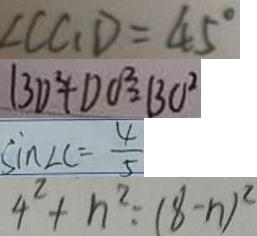Convert formula to latex. <formula><loc_0><loc_0><loc_500><loc_500>\angle C C _ { 1 } D = 4 5 ^ { \circ } 
 B D ^ { 2 } + D O ^ { 2 } = B O ^ { 2 } 
 \sin \angle C = \frac { 4 } { 5 } 
 4 ^ { 2 } + n ^ { 2 } : ( 8 - n ) ^ { 2 }</formula> 